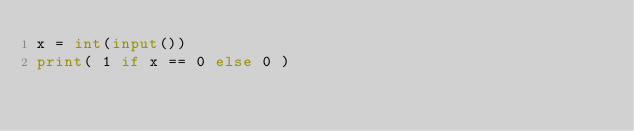Convert code to text. <code><loc_0><loc_0><loc_500><loc_500><_Python_>x = int(input())
print( 1 if x == 0 else 0 )
</code> 